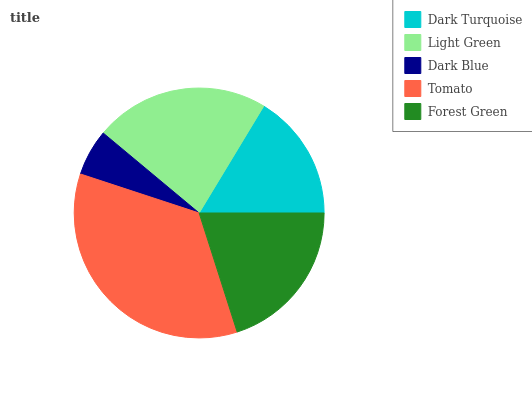Is Dark Blue the minimum?
Answer yes or no. Yes. Is Tomato the maximum?
Answer yes or no. Yes. Is Light Green the minimum?
Answer yes or no. No. Is Light Green the maximum?
Answer yes or no. No. Is Light Green greater than Dark Turquoise?
Answer yes or no. Yes. Is Dark Turquoise less than Light Green?
Answer yes or no. Yes. Is Dark Turquoise greater than Light Green?
Answer yes or no. No. Is Light Green less than Dark Turquoise?
Answer yes or no. No. Is Forest Green the high median?
Answer yes or no. Yes. Is Forest Green the low median?
Answer yes or no. Yes. Is Tomato the high median?
Answer yes or no. No. Is Tomato the low median?
Answer yes or no. No. 